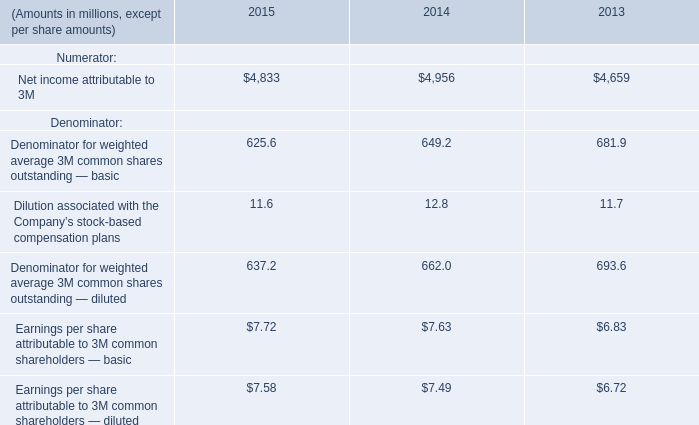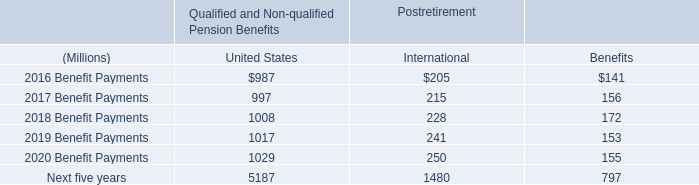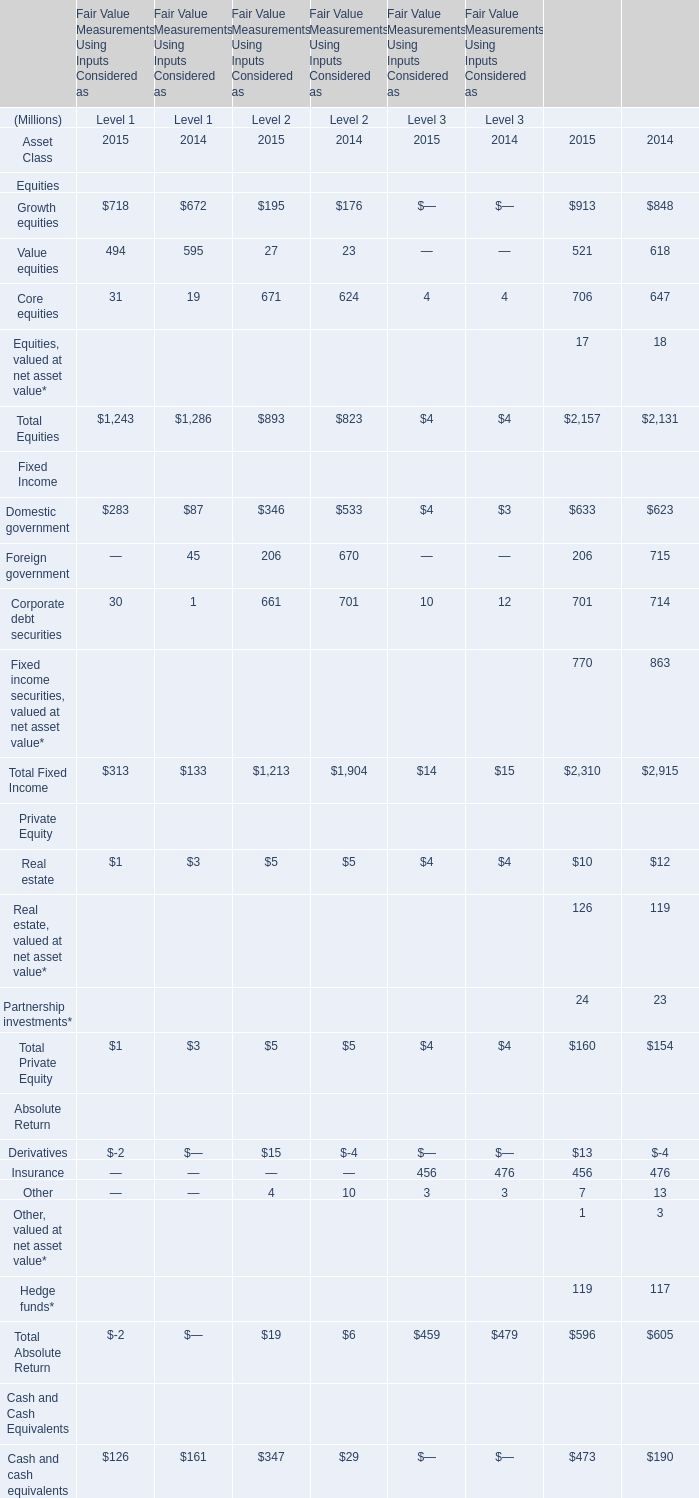Which Level is Total Fixed Income the highest in 2015? 
Answer: 2. 